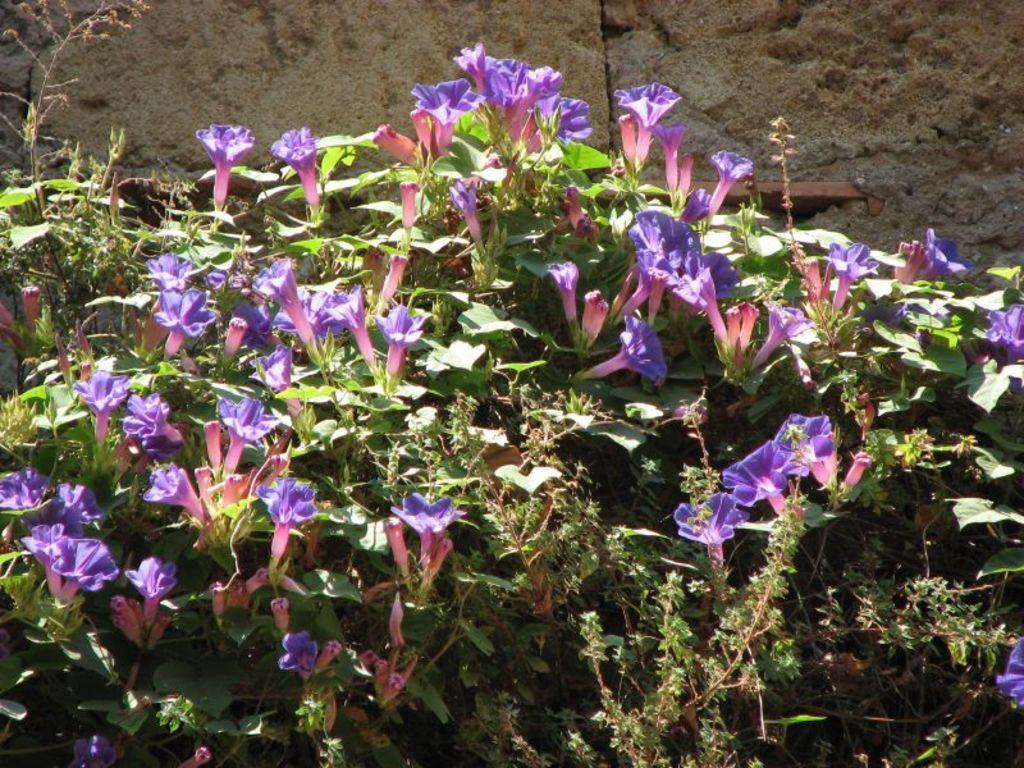What type of living organisms can be seen in the image? Plants and flowers can be seen in the image. Can you describe the background of the image? There is a wall visible behind the plants in the image. What type of mountain can be seen in the image? There is no mountain present in the image; it features plants and flowers with a wall in the background. 